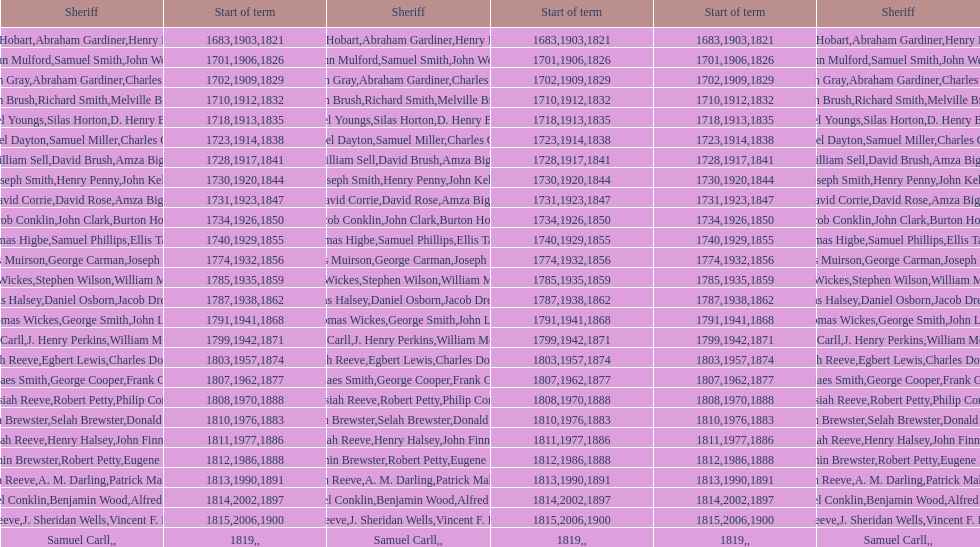Did robert petty serve before josiah reeve? No. 